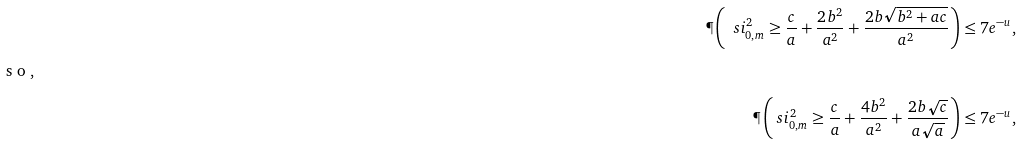Convert formula to latex. <formula><loc_0><loc_0><loc_500><loc_500>\P \left ( \ s i ^ { 2 } _ { 0 , m } \geq \frac { c } { a } + \frac { 2 b ^ { 2 } } { a ^ { 2 } } + \frac { 2 b \sqrt { b ^ { 2 } + a c } } { a ^ { 2 } } \right ) & \leq 7 e ^ { - u } , \intertext { s o , } \P \left ( \ s i ^ { 2 } _ { 0 , m } \geq \frac { c } { a } + \frac { 4 b ^ { 2 } } { a ^ { 2 } } + \frac { 2 b \sqrt { c } } { a \sqrt { a } } \right ) & \leq 7 e ^ { - u } ,</formula> 